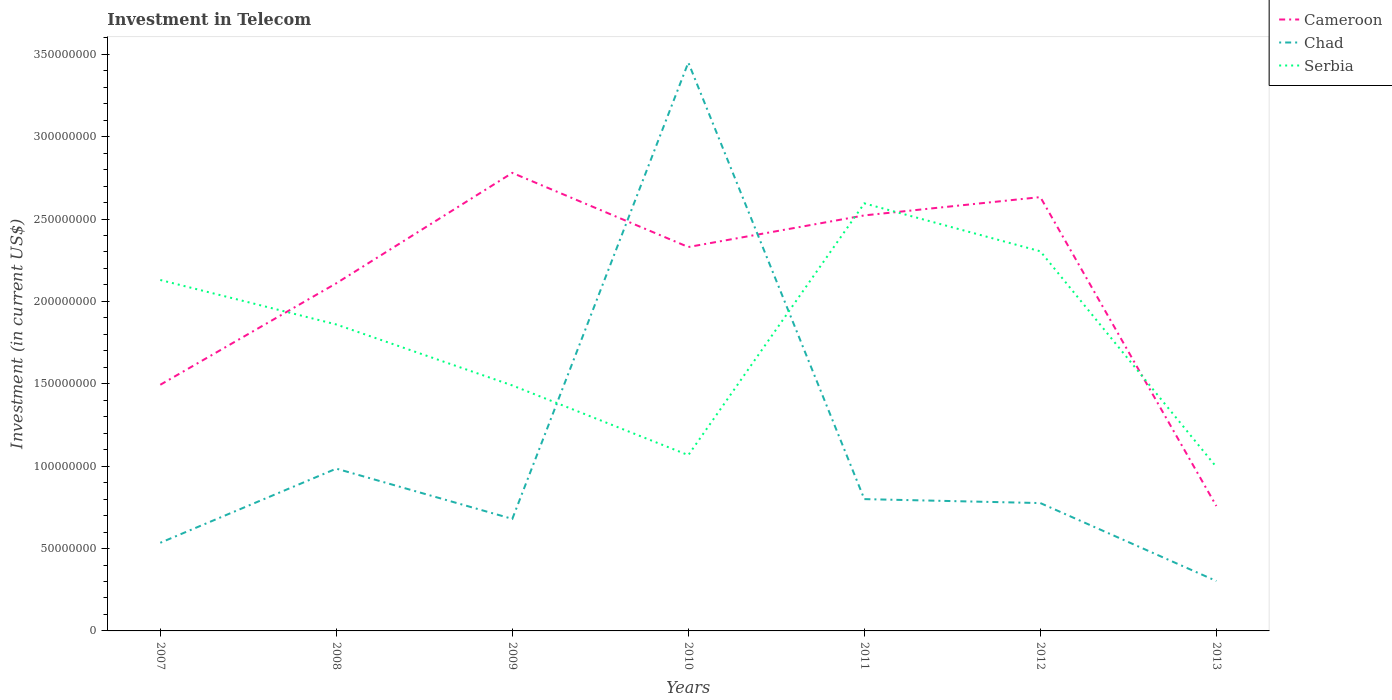Is the number of lines equal to the number of legend labels?
Provide a short and direct response. Yes. Across all years, what is the maximum amount invested in telecom in Serbia?
Your response must be concise. 9.95e+07. What is the total amount invested in telecom in Serbia in the graph?
Your answer should be very brief. -1.10e+08. What is the difference between the highest and the second highest amount invested in telecom in Cameroon?
Your response must be concise. 2.02e+08. What is the difference between the highest and the lowest amount invested in telecom in Serbia?
Offer a terse response. 4. Is the amount invested in telecom in Serbia strictly greater than the amount invested in telecom in Chad over the years?
Keep it short and to the point. No. How many lines are there?
Ensure brevity in your answer.  3. Where does the legend appear in the graph?
Provide a succinct answer. Top right. What is the title of the graph?
Your answer should be very brief. Investment in Telecom. Does "Ireland" appear as one of the legend labels in the graph?
Give a very brief answer. No. What is the label or title of the Y-axis?
Give a very brief answer. Investment (in current US$). What is the Investment (in current US$) of Cameroon in 2007?
Offer a very short reply. 1.49e+08. What is the Investment (in current US$) in Chad in 2007?
Provide a succinct answer. 5.35e+07. What is the Investment (in current US$) in Serbia in 2007?
Your answer should be compact. 2.13e+08. What is the Investment (in current US$) in Cameroon in 2008?
Make the answer very short. 2.11e+08. What is the Investment (in current US$) in Chad in 2008?
Your response must be concise. 9.85e+07. What is the Investment (in current US$) of Serbia in 2008?
Keep it short and to the point. 1.86e+08. What is the Investment (in current US$) of Cameroon in 2009?
Make the answer very short. 2.78e+08. What is the Investment (in current US$) of Chad in 2009?
Offer a very short reply. 6.80e+07. What is the Investment (in current US$) in Serbia in 2009?
Provide a succinct answer. 1.49e+08. What is the Investment (in current US$) of Cameroon in 2010?
Your answer should be compact. 2.33e+08. What is the Investment (in current US$) in Chad in 2010?
Offer a very short reply. 3.45e+08. What is the Investment (in current US$) of Serbia in 2010?
Keep it short and to the point. 1.07e+08. What is the Investment (in current US$) in Cameroon in 2011?
Provide a short and direct response. 2.52e+08. What is the Investment (in current US$) in Chad in 2011?
Offer a very short reply. 8.00e+07. What is the Investment (in current US$) of Serbia in 2011?
Offer a very short reply. 2.60e+08. What is the Investment (in current US$) in Cameroon in 2012?
Your answer should be very brief. 2.63e+08. What is the Investment (in current US$) in Chad in 2012?
Your answer should be compact. 7.76e+07. What is the Investment (in current US$) in Serbia in 2012?
Make the answer very short. 2.30e+08. What is the Investment (in current US$) in Cameroon in 2013?
Offer a very short reply. 7.58e+07. What is the Investment (in current US$) of Chad in 2013?
Offer a very short reply. 3.03e+07. What is the Investment (in current US$) in Serbia in 2013?
Your answer should be compact. 9.95e+07. Across all years, what is the maximum Investment (in current US$) in Cameroon?
Keep it short and to the point. 2.78e+08. Across all years, what is the maximum Investment (in current US$) in Chad?
Provide a short and direct response. 3.45e+08. Across all years, what is the maximum Investment (in current US$) of Serbia?
Make the answer very short. 2.60e+08. Across all years, what is the minimum Investment (in current US$) in Cameroon?
Your answer should be very brief. 7.58e+07. Across all years, what is the minimum Investment (in current US$) of Chad?
Your answer should be very brief. 3.03e+07. Across all years, what is the minimum Investment (in current US$) of Serbia?
Your answer should be compact. 9.95e+07. What is the total Investment (in current US$) of Cameroon in the graph?
Ensure brevity in your answer.  1.46e+09. What is the total Investment (in current US$) of Chad in the graph?
Your answer should be compact. 7.53e+08. What is the total Investment (in current US$) in Serbia in the graph?
Your answer should be compact. 1.24e+09. What is the difference between the Investment (in current US$) of Cameroon in 2007 and that in 2008?
Provide a short and direct response. -6.16e+07. What is the difference between the Investment (in current US$) of Chad in 2007 and that in 2008?
Provide a succinct answer. -4.50e+07. What is the difference between the Investment (in current US$) of Serbia in 2007 and that in 2008?
Your answer should be compact. 2.70e+07. What is the difference between the Investment (in current US$) in Cameroon in 2007 and that in 2009?
Make the answer very short. -1.29e+08. What is the difference between the Investment (in current US$) of Chad in 2007 and that in 2009?
Your response must be concise. -1.45e+07. What is the difference between the Investment (in current US$) of Serbia in 2007 and that in 2009?
Keep it short and to the point. 6.40e+07. What is the difference between the Investment (in current US$) in Cameroon in 2007 and that in 2010?
Keep it short and to the point. -8.36e+07. What is the difference between the Investment (in current US$) of Chad in 2007 and that in 2010?
Your response must be concise. -2.92e+08. What is the difference between the Investment (in current US$) in Serbia in 2007 and that in 2010?
Your response must be concise. 1.06e+08. What is the difference between the Investment (in current US$) in Cameroon in 2007 and that in 2011?
Provide a short and direct response. -1.03e+08. What is the difference between the Investment (in current US$) in Chad in 2007 and that in 2011?
Provide a succinct answer. -2.65e+07. What is the difference between the Investment (in current US$) of Serbia in 2007 and that in 2011?
Your response must be concise. -4.65e+07. What is the difference between the Investment (in current US$) of Cameroon in 2007 and that in 2012?
Your answer should be compact. -1.14e+08. What is the difference between the Investment (in current US$) of Chad in 2007 and that in 2012?
Provide a succinct answer. -2.41e+07. What is the difference between the Investment (in current US$) of Serbia in 2007 and that in 2012?
Offer a very short reply. -1.74e+07. What is the difference between the Investment (in current US$) of Cameroon in 2007 and that in 2013?
Keep it short and to the point. 7.36e+07. What is the difference between the Investment (in current US$) in Chad in 2007 and that in 2013?
Your response must be concise. 2.32e+07. What is the difference between the Investment (in current US$) of Serbia in 2007 and that in 2013?
Provide a short and direct response. 1.14e+08. What is the difference between the Investment (in current US$) of Cameroon in 2008 and that in 2009?
Offer a terse response. -6.70e+07. What is the difference between the Investment (in current US$) of Chad in 2008 and that in 2009?
Your answer should be very brief. 3.05e+07. What is the difference between the Investment (in current US$) of Serbia in 2008 and that in 2009?
Provide a short and direct response. 3.70e+07. What is the difference between the Investment (in current US$) in Cameroon in 2008 and that in 2010?
Make the answer very short. -2.20e+07. What is the difference between the Investment (in current US$) of Chad in 2008 and that in 2010?
Give a very brief answer. -2.46e+08. What is the difference between the Investment (in current US$) in Serbia in 2008 and that in 2010?
Provide a succinct answer. 7.93e+07. What is the difference between the Investment (in current US$) of Cameroon in 2008 and that in 2011?
Your answer should be compact. -4.12e+07. What is the difference between the Investment (in current US$) in Chad in 2008 and that in 2011?
Provide a short and direct response. 1.85e+07. What is the difference between the Investment (in current US$) of Serbia in 2008 and that in 2011?
Provide a succinct answer. -7.35e+07. What is the difference between the Investment (in current US$) in Cameroon in 2008 and that in 2012?
Give a very brief answer. -5.23e+07. What is the difference between the Investment (in current US$) of Chad in 2008 and that in 2012?
Offer a very short reply. 2.09e+07. What is the difference between the Investment (in current US$) in Serbia in 2008 and that in 2012?
Your response must be concise. -4.44e+07. What is the difference between the Investment (in current US$) in Cameroon in 2008 and that in 2013?
Keep it short and to the point. 1.35e+08. What is the difference between the Investment (in current US$) of Chad in 2008 and that in 2013?
Ensure brevity in your answer.  6.82e+07. What is the difference between the Investment (in current US$) in Serbia in 2008 and that in 2013?
Offer a very short reply. 8.65e+07. What is the difference between the Investment (in current US$) of Cameroon in 2009 and that in 2010?
Your response must be concise. 4.50e+07. What is the difference between the Investment (in current US$) of Chad in 2009 and that in 2010?
Give a very brief answer. -2.77e+08. What is the difference between the Investment (in current US$) of Serbia in 2009 and that in 2010?
Your answer should be very brief. 4.23e+07. What is the difference between the Investment (in current US$) in Cameroon in 2009 and that in 2011?
Keep it short and to the point. 2.58e+07. What is the difference between the Investment (in current US$) of Chad in 2009 and that in 2011?
Your answer should be compact. -1.20e+07. What is the difference between the Investment (in current US$) in Serbia in 2009 and that in 2011?
Provide a short and direct response. -1.10e+08. What is the difference between the Investment (in current US$) of Cameroon in 2009 and that in 2012?
Provide a succinct answer. 1.47e+07. What is the difference between the Investment (in current US$) in Chad in 2009 and that in 2012?
Provide a succinct answer. -9.60e+06. What is the difference between the Investment (in current US$) in Serbia in 2009 and that in 2012?
Provide a succinct answer. -8.14e+07. What is the difference between the Investment (in current US$) of Cameroon in 2009 and that in 2013?
Make the answer very short. 2.02e+08. What is the difference between the Investment (in current US$) of Chad in 2009 and that in 2013?
Your response must be concise. 3.77e+07. What is the difference between the Investment (in current US$) in Serbia in 2009 and that in 2013?
Give a very brief answer. 4.95e+07. What is the difference between the Investment (in current US$) in Cameroon in 2010 and that in 2011?
Give a very brief answer. -1.92e+07. What is the difference between the Investment (in current US$) in Chad in 2010 and that in 2011?
Give a very brief answer. 2.65e+08. What is the difference between the Investment (in current US$) of Serbia in 2010 and that in 2011?
Provide a short and direct response. -1.53e+08. What is the difference between the Investment (in current US$) in Cameroon in 2010 and that in 2012?
Your answer should be very brief. -3.03e+07. What is the difference between the Investment (in current US$) of Chad in 2010 and that in 2012?
Your answer should be compact. 2.67e+08. What is the difference between the Investment (in current US$) of Serbia in 2010 and that in 2012?
Give a very brief answer. -1.24e+08. What is the difference between the Investment (in current US$) of Cameroon in 2010 and that in 2013?
Keep it short and to the point. 1.57e+08. What is the difference between the Investment (in current US$) of Chad in 2010 and that in 2013?
Give a very brief answer. 3.15e+08. What is the difference between the Investment (in current US$) of Serbia in 2010 and that in 2013?
Your response must be concise. 7.20e+06. What is the difference between the Investment (in current US$) in Cameroon in 2011 and that in 2012?
Ensure brevity in your answer.  -1.11e+07. What is the difference between the Investment (in current US$) in Chad in 2011 and that in 2012?
Provide a succinct answer. 2.40e+06. What is the difference between the Investment (in current US$) of Serbia in 2011 and that in 2012?
Your answer should be very brief. 2.91e+07. What is the difference between the Investment (in current US$) in Cameroon in 2011 and that in 2013?
Make the answer very short. 1.76e+08. What is the difference between the Investment (in current US$) of Chad in 2011 and that in 2013?
Ensure brevity in your answer.  4.97e+07. What is the difference between the Investment (in current US$) in Serbia in 2011 and that in 2013?
Give a very brief answer. 1.60e+08. What is the difference between the Investment (in current US$) in Cameroon in 2012 and that in 2013?
Your answer should be compact. 1.88e+08. What is the difference between the Investment (in current US$) in Chad in 2012 and that in 2013?
Your answer should be very brief. 4.73e+07. What is the difference between the Investment (in current US$) in Serbia in 2012 and that in 2013?
Offer a terse response. 1.31e+08. What is the difference between the Investment (in current US$) in Cameroon in 2007 and the Investment (in current US$) in Chad in 2008?
Offer a terse response. 5.09e+07. What is the difference between the Investment (in current US$) of Cameroon in 2007 and the Investment (in current US$) of Serbia in 2008?
Keep it short and to the point. -3.66e+07. What is the difference between the Investment (in current US$) in Chad in 2007 and the Investment (in current US$) in Serbia in 2008?
Provide a succinct answer. -1.32e+08. What is the difference between the Investment (in current US$) in Cameroon in 2007 and the Investment (in current US$) in Chad in 2009?
Your response must be concise. 8.14e+07. What is the difference between the Investment (in current US$) of Chad in 2007 and the Investment (in current US$) of Serbia in 2009?
Your answer should be very brief. -9.55e+07. What is the difference between the Investment (in current US$) in Cameroon in 2007 and the Investment (in current US$) in Chad in 2010?
Ensure brevity in your answer.  -1.96e+08. What is the difference between the Investment (in current US$) of Cameroon in 2007 and the Investment (in current US$) of Serbia in 2010?
Ensure brevity in your answer.  4.27e+07. What is the difference between the Investment (in current US$) of Chad in 2007 and the Investment (in current US$) of Serbia in 2010?
Your answer should be compact. -5.32e+07. What is the difference between the Investment (in current US$) in Cameroon in 2007 and the Investment (in current US$) in Chad in 2011?
Your answer should be very brief. 6.94e+07. What is the difference between the Investment (in current US$) in Cameroon in 2007 and the Investment (in current US$) in Serbia in 2011?
Offer a very short reply. -1.10e+08. What is the difference between the Investment (in current US$) of Chad in 2007 and the Investment (in current US$) of Serbia in 2011?
Make the answer very short. -2.06e+08. What is the difference between the Investment (in current US$) of Cameroon in 2007 and the Investment (in current US$) of Chad in 2012?
Keep it short and to the point. 7.18e+07. What is the difference between the Investment (in current US$) in Cameroon in 2007 and the Investment (in current US$) in Serbia in 2012?
Your response must be concise. -8.10e+07. What is the difference between the Investment (in current US$) in Chad in 2007 and the Investment (in current US$) in Serbia in 2012?
Your response must be concise. -1.77e+08. What is the difference between the Investment (in current US$) of Cameroon in 2007 and the Investment (in current US$) of Chad in 2013?
Provide a short and direct response. 1.19e+08. What is the difference between the Investment (in current US$) in Cameroon in 2007 and the Investment (in current US$) in Serbia in 2013?
Keep it short and to the point. 4.99e+07. What is the difference between the Investment (in current US$) of Chad in 2007 and the Investment (in current US$) of Serbia in 2013?
Your response must be concise. -4.60e+07. What is the difference between the Investment (in current US$) in Cameroon in 2008 and the Investment (in current US$) in Chad in 2009?
Your response must be concise. 1.43e+08. What is the difference between the Investment (in current US$) in Cameroon in 2008 and the Investment (in current US$) in Serbia in 2009?
Provide a short and direct response. 6.20e+07. What is the difference between the Investment (in current US$) of Chad in 2008 and the Investment (in current US$) of Serbia in 2009?
Offer a terse response. -5.05e+07. What is the difference between the Investment (in current US$) of Cameroon in 2008 and the Investment (in current US$) of Chad in 2010?
Offer a very short reply. -1.34e+08. What is the difference between the Investment (in current US$) in Cameroon in 2008 and the Investment (in current US$) in Serbia in 2010?
Your answer should be very brief. 1.04e+08. What is the difference between the Investment (in current US$) in Chad in 2008 and the Investment (in current US$) in Serbia in 2010?
Provide a short and direct response. -8.20e+06. What is the difference between the Investment (in current US$) of Cameroon in 2008 and the Investment (in current US$) of Chad in 2011?
Offer a terse response. 1.31e+08. What is the difference between the Investment (in current US$) in Cameroon in 2008 and the Investment (in current US$) in Serbia in 2011?
Make the answer very short. -4.85e+07. What is the difference between the Investment (in current US$) in Chad in 2008 and the Investment (in current US$) in Serbia in 2011?
Make the answer very short. -1.61e+08. What is the difference between the Investment (in current US$) of Cameroon in 2008 and the Investment (in current US$) of Chad in 2012?
Provide a succinct answer. 1.33e+08. What is the difference between the Investment (in current US$) in Cameroon in 2008 and the Investment (in current US$) in Serbia in 2012?
Keep it short and to the point. -1.94e+07. What is the difference between the Investment (in current US$) in Chad in 2008 and the Investment (in current US$) in Serbia in 2012?
Keep it short and to the point. -1.32e+08. What is the difference between the Investment (in current US$) in Cameroon in 2008 and the Investment (in current US$) in Chad in 2013?
Ensure brevity in your answer.  1.81e+08. What is the difference between the Investment (in current US$) of Cameroon in 2008 and the Investment (in current US$) of Serbia in 2013?
Your response must be concise. 1.12e+08. What is the difference between the Investment (in current US$) of Chad in 2008 and the Investment (in current US$) of Serbia in 2013?
Your answer should be compact. -1.00e+06. What is the difference between the Investment (in current US$) in Cameroon in 2009 and the Investment (in current US$) in Chad in 2010?
Provide a short and direct response. -6.70e+07. What is the difference between the Investment (in current US$) of Cameroon in 2009 and the Investment (in current US$) of Serbia in 2010?
Offer a terse response. 1.71e+08. What is the difference between the Investment (in current US$) in Chad in 2009 and the Investment (in current US$) in Serbia in 2010?
Provide a succinct answer. -3.87e+07. What is the difference between the Investment (in current US$) in Cameroon in 2009 and the Investment (in current US$) in Chad in 2011?
Give a very brief answer. 1.98e+08. What is the difference between the Investment (in current US$) in Cameroon in 2009 and the Investment (in current US$) in Serbia in 2011?
Your response must be concise. 1.85e+07. What is the difference between the Investment (in current US$) in Chad in 2009 and the Investment (in current US$) in Serbia in 2011?
Your answer should be compact. -1.92e+08. What is the difference between the Investment (in current US$) in Cameroon in 2009 and the Investment (in current US$) in Chad in 2012?
Give a very brief answer. 2.00e+08. What is the difference between the Investment (in current US$) of Cameroon in 2009 and the Investment (in current US$) of Serbia in 2012?
Keep it short and to the point. 4.76e+07. What is the difference between the Investment (in current US$) in Chad in 2009 and the Investment (in current US$) in Serbia in 2012?
Your answer should be very brief. -1.62e+08. What is the difference between the Investment (in current US$) in Cameroon in 2009 and the Investment (in current US$) in Chad in 2013?
Your answer should be very brief. 2.48e+08. What is the difference between the Investment (in current US$) of Cameroon in 2009 and the Investment (in current US$) of Serbia in 2013?
Provide a short and direct response. 1.78e+08. What is the difference between the Investment (in current US$) in Chad in 2009 and the Investment (in current US$) in Serbia in 2013?
Offer a terse response. -3.15e+07. What is the difference between the Investment (in current US$) in Cameroon in 2010 and the Investment (in current US$) in Chad in 2011?
Offer a very short reply. 1.53e+08. What is the difference between the Investment (in current US$) of Cameroon in 2010 and the Investment (in current US$) of Serbia in 2011?
Provide a succinct answer. -2.65e+07. What is the difference between the Investment (in current US$) in Chad in 2010 and the Investment (in current US$) in Serbia in 2011?
Give a very brief answer. 8.55e+07. What is the difference between the Investment (in current US$) in Cameroon in 2010 and the Investment (in current US$) in Chad in 2012?
Offer a terse response. 1.55e+08. What is the difference between the Investment (in current US$) in Cameroon in 2010 and the Investment (in current US$) in Serbia in 2012?
Your response must be concise. 2.60e+06. What is the difference between the Investment (in current US$) of Chad in 2010 and the Investment (in current US$) of Serbia in 2012?
Your answer should be very brief. 1.15e+08. What is the difference between the Investment (in current US$) of Cameroon in 2010 and the Investment (in current US$) of Chad in 2013?
Ensure brevity in your answer.  2.03e+08. What is the difference between the Investment (in current US$) of Cameroon in 2010 and the Investment (in current US$) of Serbia in 2013?
Provide a succinct answer. 1.34e+08. What is the difference between the Investment (in current US$) in Chad in 2010 and the Investment (in current US$) in Serbia in 2013?
Your answer should be very brief. 2.46e+08. What is the difference between the Investment (in current US$) of Cameroon in 2011 and the Investment (in current US$) of Chad in 2012?
Your answer should be very brief. 1.75e+08. What is the difference between the Investment (in current US$) of Cameroon in 2011 and the Investment (in current US$) of Serbia in 2012?
Make the answer very short. 2.18e+07. What is the difference between the Investment (in current US$) in Chad in 2011 and the Investment (in current US$) in Serbia in 2012?
Offer a terse response. -1.50e+08. What is the difference between the Investment (in current US$) of Cameroon in 2011 and the Investment (in current US$) of Chad in 2013?
Your answer should be compact. 2.22e+08. What is the difference between the Investment (in current US$) in Cameroon in 2011 and the Investment (in current US$) in Serbia in 2013?
Ensure brevity in your answer.  1.53e+08. What is the difference between the Investment (in current US$) of Chad in 2011 and the Investment (in current US$) of Serbia in 2013?
Your answer should be compact. -1.95e+07. What is the difference between the Investment (in current US$) in Cameroon in 2012 and the Investment (in current US$) in Chad in 2013?
Make the answer very short. 2.33e+08. What is the difference between the Investment (in current US$) in Cameroon in 2012 and the Investment (in current US$) in Serbia in 2013?
Give a very brief answer. 1.64e+08. What is the difference between the Investment (in current US$) in Chad in 2012 and the Investment (in current US$) in Serbia in 2013?
Your response must be concise. -2.19e+07. What is the average Investment (in current US$) of Cameroon per year?
Provide a short and direct response. 2.09e+08. What is the average Investment (in current US$) in Chad per year?
Your answer should be very brief. 1.08e+08. What is the average Investment (in current US$) in Serbia per year?
Your response must be concise. 1.78e+08. In the year 2007, what is the difference between the Investment (in current US$) of Cameroon and Investment (in current US$) of Chad?
Offer a very short reply. 9.59e+07. In the year 2007, what is the difference between the Investment (in current US$) of Cameroon and Investment (in current US$) of Serbia?
Provide a succinct answer. -6.36e+07. In the year 2007, what is the difference between the Investment (in current US$) in Chad and Investment (in current US$) in Serbia?
Provide a succinct answer. -1.60e+08. In the year 2008, what is the difference between the Investment (in current US$) in Cameroon and Investment (in current US$) in Chad?
Provide a succinct answer. 1.12e+08. In the year 2008, what is the difference between the Investment (in current US$) in Cameroon and Investment (in current US$) in Serbia?
Your answer should be very brief. 2.50e+07. In the year 2008, what is the difference between the Investment (in current US$) in Chad and Investment (in current US$) in Serbia?
Give a very brief answer. -8.75e+07. In the year 2009, what is the difference between the Investment (in current US$) of Cameroon and Investment (in current US$) of Chad?
Your response must be concise. 2.10e+08. In the year 2009, what is the difference between the Investment (in current US$) in Cameroon and Investment (in current US$) in Serbia?
Offer a very short reply. 1.29e+08. In the year 2009, what is the difference between the Investment (in current US$) of Chad and Investment (in current US$) of Serbia?
Your answer should be very brief. -8.10e+07. In the year 2010, what is the difference between the Investment (in current US$) in Cameroon and Investment (in current US$) in Chad?
Give a very brief answer. -1.12e+08. In the year 2010, what is the difference between the Investment (in current US$) in Cameroon and Investment (in current US$) in Serbia?
Offer a terse response. 1.26e+08. In the year 2010, what is the difference between the Investment (in current US$) of Chad and Investment (in current US$) of Serbia?
Your response must be concise. 2.38e+08. In the year 2011, what is the difference between the Investment (in current US$) in Cameroon and Investment (in current US$) in Chad?
Ensure brevity in your answer.  1.72e+08. In the year 2011, what is the difference between the Investment (in current US$) of Cameroon and Investment (in current US$) of Serbia?
Give a very brief answer. -7.30e+06. In the year 2011, what is the difference between the Investment (in current US$) of Chad and Investment (in current US$) of Serbia?
Provide a succinct answer. -1.80e+08. In the year 2012, what is the difference between the Investment (in current US$) in Cameroon and Investment (in current US$) in Chad?
Offer a very short reply. 1.86e+08. In the year 2012, what is the difference between the Investment (in current US$) of Cameroon and Investment (in current US$) of Serbia?
Provide a succinct answer. 3.29e+07. In the year 2012, what is the difference between the Investment (in current US$) in Chad and Investment (in current US$) in Serbia?
Ensure brevity in your answer.  -1.53e+08. In the year 2013, what is the difference between the Investment (in current US$) in Cameroon and Investment (in current US$) in Chad?
Offer a very short reply. 4.55e+07. In the year 2013, what is the difference between the Investment (in current US$) of Cameroon and Investment (in current US$) of Serbia?
Provide a short and direct response. -2.37e+07. In the year 2013, what is the difference between the Investment (in current US$) in Chad and Investment (in current US$) in Serbia?
Keep it short and to the point. -6.92e+07. What is the ratio of the Investment (in current US$) of Cameroon in 2007 to that in 2008?
Offer a very short reply. 0.71. What is the ratio of the Investment (in current US$) in Chad in 2007 to that in 2008?
Ensure brevity in your answer.  0.54. What is the ratio of the Investment (in current US$) in Serbia in 2007 to that in 2008?
Keep it short and to the point. 1.15. What is the ratio of the Investment (in current US$) in Cameroon in 2007 to that in 2009?
Keep it short and to the point. 0.54. What is the ratio of the Investment (in current US$) in Chad in 2007 to that in 2009?
Offer a very short reply. 0.79. What is the ratio of the Investment (in current US$) of Serbia in 2007 to that in 2009?
Your answer should be very brief. 1.43. What is the ratio of the Investment (in current US$) of Cameroon in 2007 to that in 2010?
Offer a terse response. 0.64. What is the ratio of the Investment (in current US$) in Chad in 2007 to that in 2010?
Keep it short and to the point. 0.16. What is the ratio of the Investment (in current US$) of Serbia in 2007 to that in 2010?
Offer a terse response. 2. What is the ratio of the Investment (in current US$) of Cameroon in 2007 to that in 2011?
Give a very brief answer. 0.59. What is the ratio of the Investment (in current US$) of Chad in 2007 to that in 2011?
Ensure brevity in your answer.  0.67. What is the ratio of the Investment (in current US$) of Serbia in 2007 to that in 2011?
Provide a succinct answer. 0.82. What is the ratio of the Investment (in current US$) of Cameroon in 2007 to that in 2012?
Provide a succinct answer. 0.57. What is the ratio of the Investment (in current US$) in Chad in 2007 to that in 2012?
Provide a short and direct response. 0.69. What is the ratio of the Investment (in current US$) in Serbia in 2007 to that in 2012?
Your answer should be very brief. 0.92. What is the ratio of the Investment (in current US$) of Cameroon in 2007 to that in 2013?
Make the answer very short. 1.97. What is the ratio of the Investment (in current US$) of Chad in 2007 to that in 2013?
Make the answer very short. 1.77. What is the ratio of the Investment (in current US$) in Serbia in 2007 to that in 2013?
Provide a succinct answer. 2.14. What is the ratio of the Investment (in current US$) in Cameroon in 2008 to that in 2009?
Give a very brief answer. 0.76. What is the ratio of the Investment (in current US$) in Chad in 2008 to that in 2009?
Make the answer very short. 1.45. What is the ratio of the Investment (in current US$) of Serbia in 2008 to that in 2009?
Your response must be concise. 1.25. What is the ratio of the Investment (in current US$) in Cameroon in 2008 to that in 2010?
Offer a terse response. 0.91. What is the ratio of the Investment (in current US$) of Chad in 2008 to that in 2010?
Keep it short and to the point. 0.29. What is the ratio of the Investment (in current US$) of Serbia in 2008 to that in 2010?
Keep it short and to the point. 1.74. What is the ratio of the Investment (in current US$) of Cameroon in 2008 to that in 2011?
Offer a terse response. 0.84. What is the ratio of the Investment (in current US$) in Chad in 2008 to that in 2011?
Your answer should be compact. 1.23. What is the ratio of the Investment (in current US$) in Serbia in 2008 to that in 2011?
Ensure brevity in your answer.  0.72. What is the ratio of the Investment (in current US$) of Cameroon in 2008 to that in 2012?
Keep it short and to the point. 0.8. What is the ratio of the Investment (in current US$) in Chad in 2008 to that in 2012?
Offer a very short reply. 1.27. What is the ratio of the Investment (in current US$) in Serbia in 2008 to that in 2012?
Offer a very short reply. 0.81. What is the ratio of the Investment (in current US$) of Cameroon in 2008 to that in 2013?
Provide a succinct answer. 2.78. What is the ratio of the Investment (in current US$) of Chad in 2008 to that in 2013?
Give a very brief answer. 3.25. What is the ratio of the Investment (in current US$) in Serbia in 2008 to that in 2013?
Provide a short and direct response. 1.87. What is the ratio of the Investment (in current US$) of Cameroon in 2009 to that in 2010?
Make the answer very short. 1.19. What is the ratio of the Investment (in current US$) of Chad in 2009 to that in 2010?
Give a very brief answer. 0.2. What is the ratio of the Investment (in current US$) of Serbia in 2009 to that in 2010?
Offer a terse response. 1.4. What is the ratio of the Investment (in current US$) of Cameroon in 2009 to that in 2011?
Offer a very short reply. 1.1. What is the ratio of the Investment (in current US$) in Chad in 2009 to that in 2011?
Your response must be concise. 0.85. What is the ratio of the Investment (in current US$) in Serbia in 2009 to that in 2011?
Ensure brevity in your answer.  0.57. What is the ratio of the Investment (in current US$) in Cameroon in 2009 to that in 2012?
Give a very brief answer. 1.06. What is the ratio of the Investment (in current US$) of Chad in 2009 to that in 2012?
Offer a terse response. 0.88. What is the ratio of the Investment (in current US$) of Serbia in 2009 to that in 2012?
Offer a very short reply. 0.65. What is the ratio of the Investment (in current US$) of Cameroon in 2009 to that in 2013?
Offer a terse response. 3.67. What is the ratio of the Investment (in current US$) of Chad in 2009 to that in 2013?
Your response must be concise. 2.24. What is the ratio of the Investment (in current US$) of Serbia in 2009 to that in 2013?
Ensure brevity in your answer.  1.5. What is the ratio of the Investment (in current US$) in Cameroon in 2010 to that in 2011?
Provide a succinct answer. 0.92. What is the ratio of the Investment (in current US$) of Chad in 2010 to that in 2011?
Your answer should be compact. 4.31. What is the ratio of the Investment (in current US$) of Serbia in 2010 to that in 2011?
Provide a succinct answer. 0.41. What is the ratio of the Investment (in current US$) in Cameroon in 2010 to that in 2012?
Ensure brevity in your answer.  0.88. What is the ratio of the Investment (in current US$) in Chad in 2010 to that in 2012?
Your answer should be compact. 4.45. What is the ratio of the Investment (in current US$) of Serbia in 2010 to that in 2012?
Give a very brief answer. 0.46. What is the ratio of the Investment (in current US$) of Cameroon in 2010 to that in 2013?
Your response must be concise. 3.07. What is the ratio of the Investment (in current US$) of Chad in 2010 to that in 2013?
Give a very brief answer. 11.39. What is the ratio of the Investment (in current US$) of Serbia in 2010 to that in 2013?
Provide a succinct answer. 1.07. What is the ratio of the Investment (in current US$) in Cameroon in 2011 to that in 2012?
Make the answer very short. 0.96. What is the ratio of the Investment (in current US$) of Chad in 2011 to that in 2012?
Provide a succinct answer. 1.03. What is the ratio of the Investment (in current US$) of Serbia in 2011 to that in 2012?
Keep it short and to the point. 1.13. What is the ratio of the Investment (in current US$) of Cameroon in 2011 to that in 2013?
Provide a succinct answer. 3.33. What is the ratio of the Investment (in current US$) of Chad in 2011 to that in 2013?
Your answer should be compact. 2.64. What is the ratio of the Investment (in current US$) in Serbia in 2011 to that in 2013?
Keep it short and to the point. 2.61. What is the ratio of the Investment (in current US$) in Cameroon in 2012 to that in 2013?
Your response must be concise. 3.47. What is the ratio of the Investment (in current US$) of Chad in 2012 to that in 2013?
Make the answer very short. 2.56. What is the ratio of the Investment (in current US$) in Serbia in 2012 to that in 2013?
Your response must be concise. 2.32. What is the difference between the highest and the second highest Investment (in current US$) of Cameroon?
Keep it short and to the point. 1.47e+07. What is the difference between the highest and the second highest Investment (in current US$) in Chad?
Ensure brevity in your answer.  2.46e+08. What is the difference between the highest and the second highest Investment (in current US$) in Serbia?
Your answer should be compact. 2.91e+07. What is the difference between the highest and the lowest Investment (in current US$) in Cameroon?
Your answer should be very brief. 2.02e+08. What is the difference between the highest and the lowest Investment (in current US$) in Chad?
Provide a short and direct response. 3.15e+08. What is the difference between the highest and the lowest Investment (in current US$) of Serbia?
Give a very brief answer. 1.60e+08. 